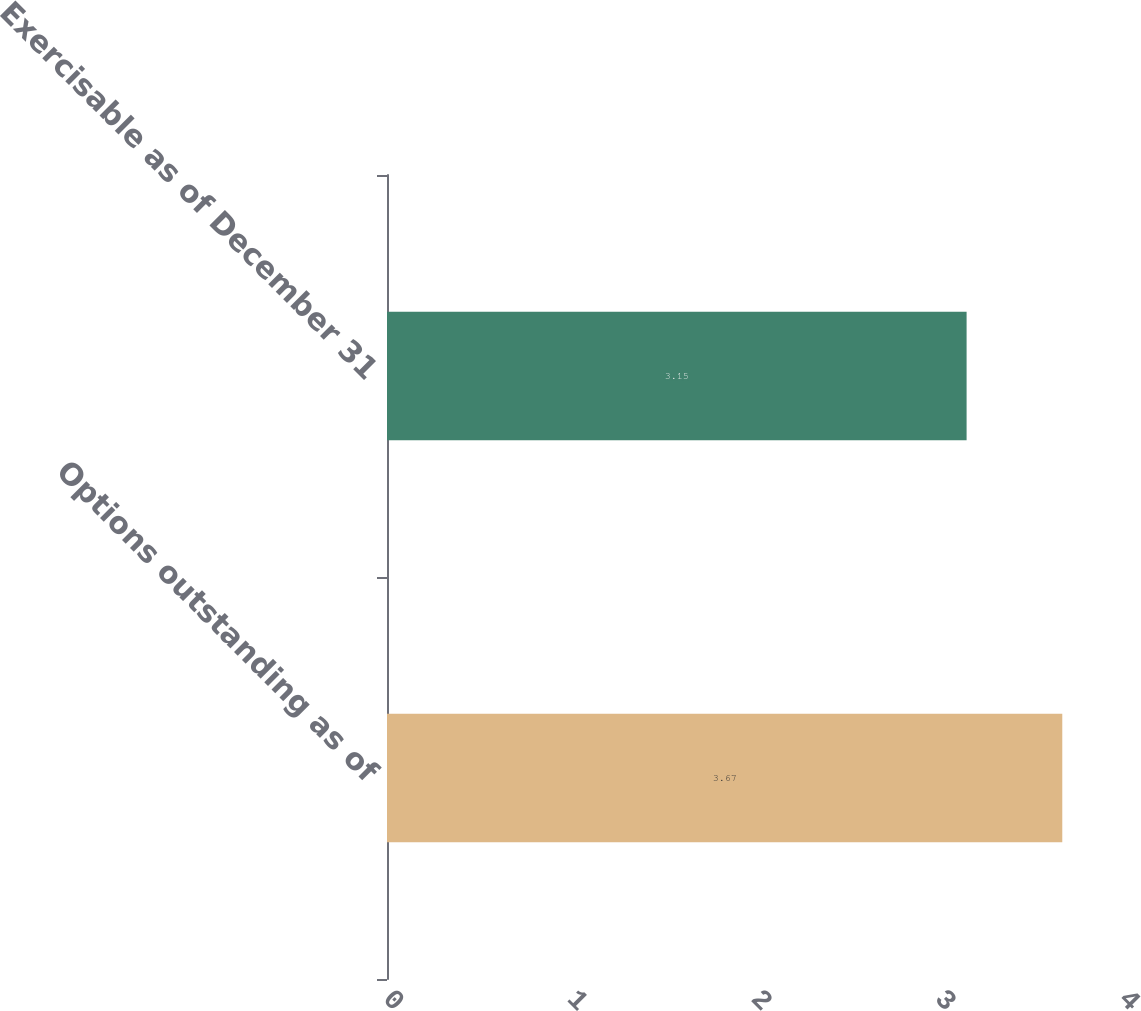Convert chart. <chart><loc_0><loc_0><loc_500><loc_500><bar_chart><fcel>Options outstanding as of<fcel>Exercisable as of December 31<nl><fcel>3.67<fcel>3.15<nl></chart> 